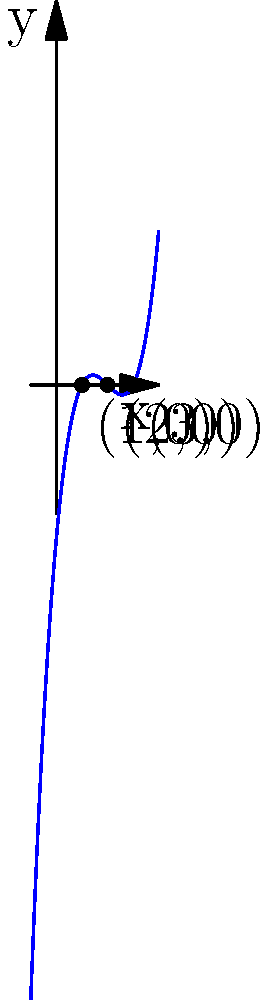As a political science student interested in law school applications, you're exploring mathematical concepts that might appear in LSAT logic games. Consider the cubic function $f(x) = x^3 - 6x^2 + 11x - 6$. Based on the graph, identify the roots of this function and explain their significance in terms of polynomial behavior. To solve this problem, let's follow these steps:

1) First, we need to understand what roots are. Roots are the x-values where the function crosses the x-axis, i.e., where $f(x) = 0$.

2) From the graph, we can see that the curve intersects the x-axis at three points: (1,0), (2,0), and (3,0).

3) This means the roots of the function are $x = 1$, $x = 2$, and $x = 3$.

4) The significance of these roots in terms of polynomial behavior:

   a) The number of roots (3) matches the degree of the polynomial (cubic or 3rd degree), which is always true for polynomials with real coefficients.
   
   b) The roots represent the factors of the polynomial. We can rewrite the function as:
      $f(x) = (x-1)(x-2)(x-3)$

   c) The behavior of the function changes at each root:
      - Below $x=1$, the function is negative
      - Between $x=1$ and $x=2$, the function is positive
      - Between $x=2$ and $x=3$, the function is negative
      - Above $x=3$, the function is positive

5) In the context of LSAT logic games, understanding such mathematical concepts can help in analyzing complex relationships and conditions, which is crucial for solving these types of problems.
Answer: The roots are 1, 2, and 3, representing the x-intercepts where the cubic function changes sign. 